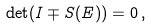<formula> <loc_0><loc_0><loc_500><loc_500>\det ( I \mp S ( E ) ) = 0 \, ,</formula> 